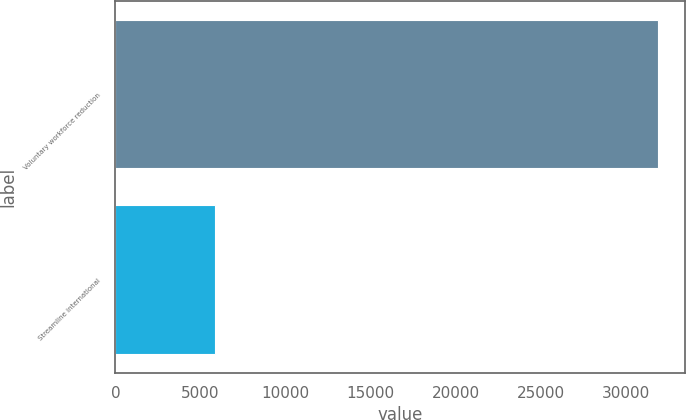Convert chart to OTSL. <chart><loc_0><loc_0><loc_500><loc_500><bar_chart><fcel>Voluntary workforce reduction<fcel>Streamline international<nl><fcel>31883<fcel>5888<nl></chart> 